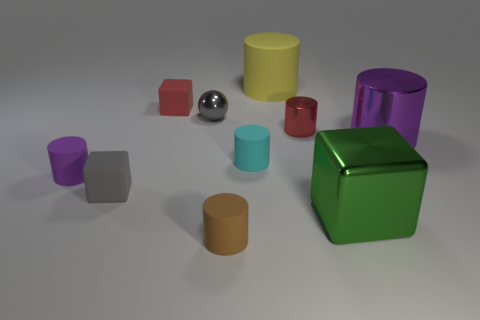Subtract all brown cylinders. How many cylinders are left? 5 Subtract all small purple matte cylinders. How many cylinders are left? 5 Subtract 1 spheres. How many spheres are left? 0 Subtract 0 yellow balls. How many objects are left? 10 Subtract all cylinders. How many objects are left? 4 Subtract all blue cylinders. Subtract all cyan blocks. How many cylinders are left? 6 Subtract all red balls. How many cyan blocks are left? 0 Subtract all tiny gray matte things. Subtract all gray matte cubes. How many objects are left? 8 Add 3 gray rubber objects. How many gray rubber objects are left? 4 Add 4 yellow objects. How many yellow objects exist? 5 